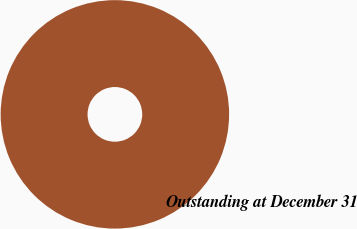<chart> <loc_0><loc_0><loc_500><loc_500><pie_chart><fcel>Outstanding at December 31<nl><fcel>100.0%<nl></chart> 